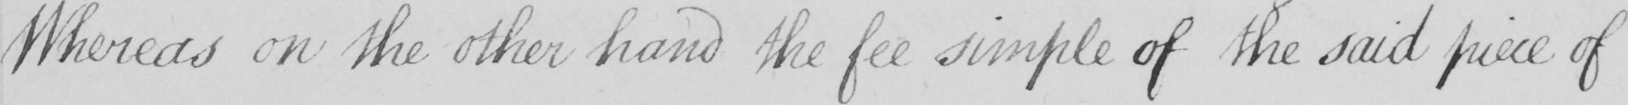Please provide the text content of this handwritten line. Whereas on the other hand the fee simple of the said piece of 